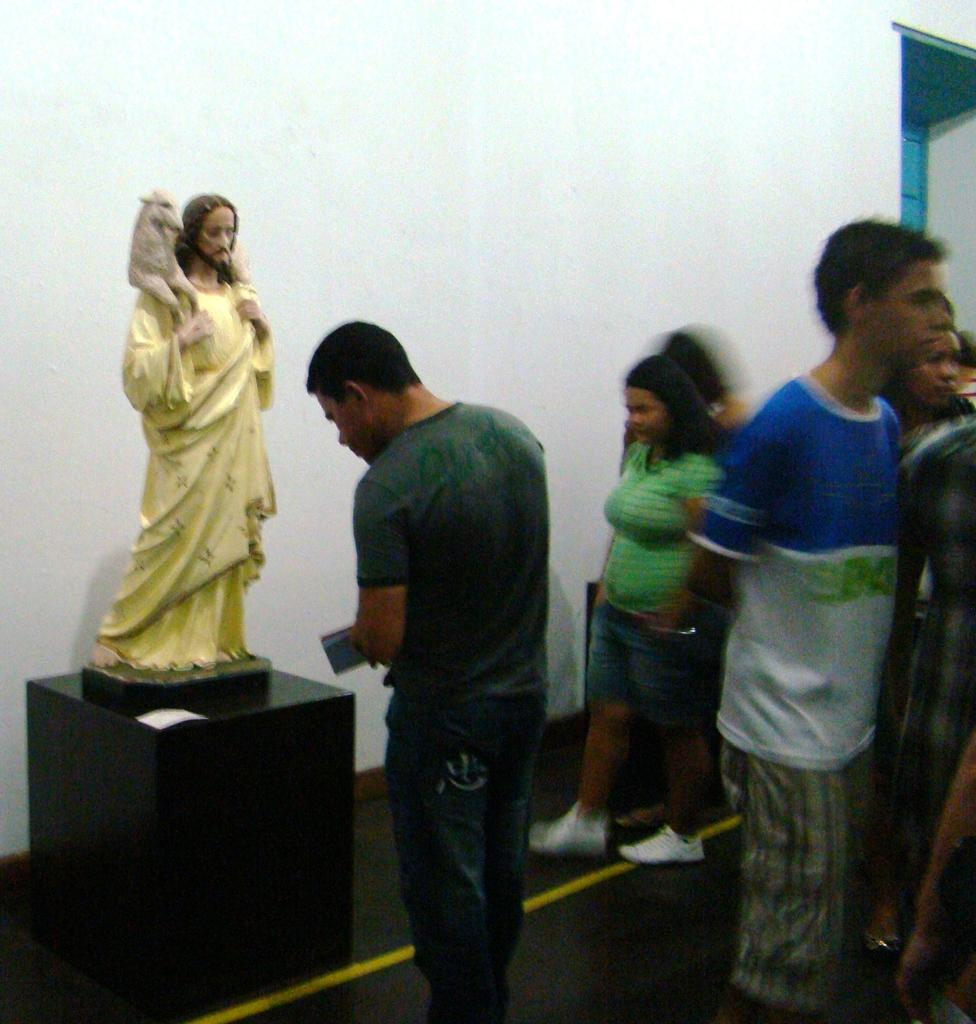What can be seen on the right side of the image? There are people standing on the right side of the image. What is located on the left side of the image? There is a sculpture on the left side of the image. What color is the wall in the background of the image? The wall in the background of the image is white. Where is the waste disposal area in the image? There is no waste disposal area present in the image. What type of transport can be seen in the image? There is no transport visible in the image; it only features people, a sculpture, and a white wall. 